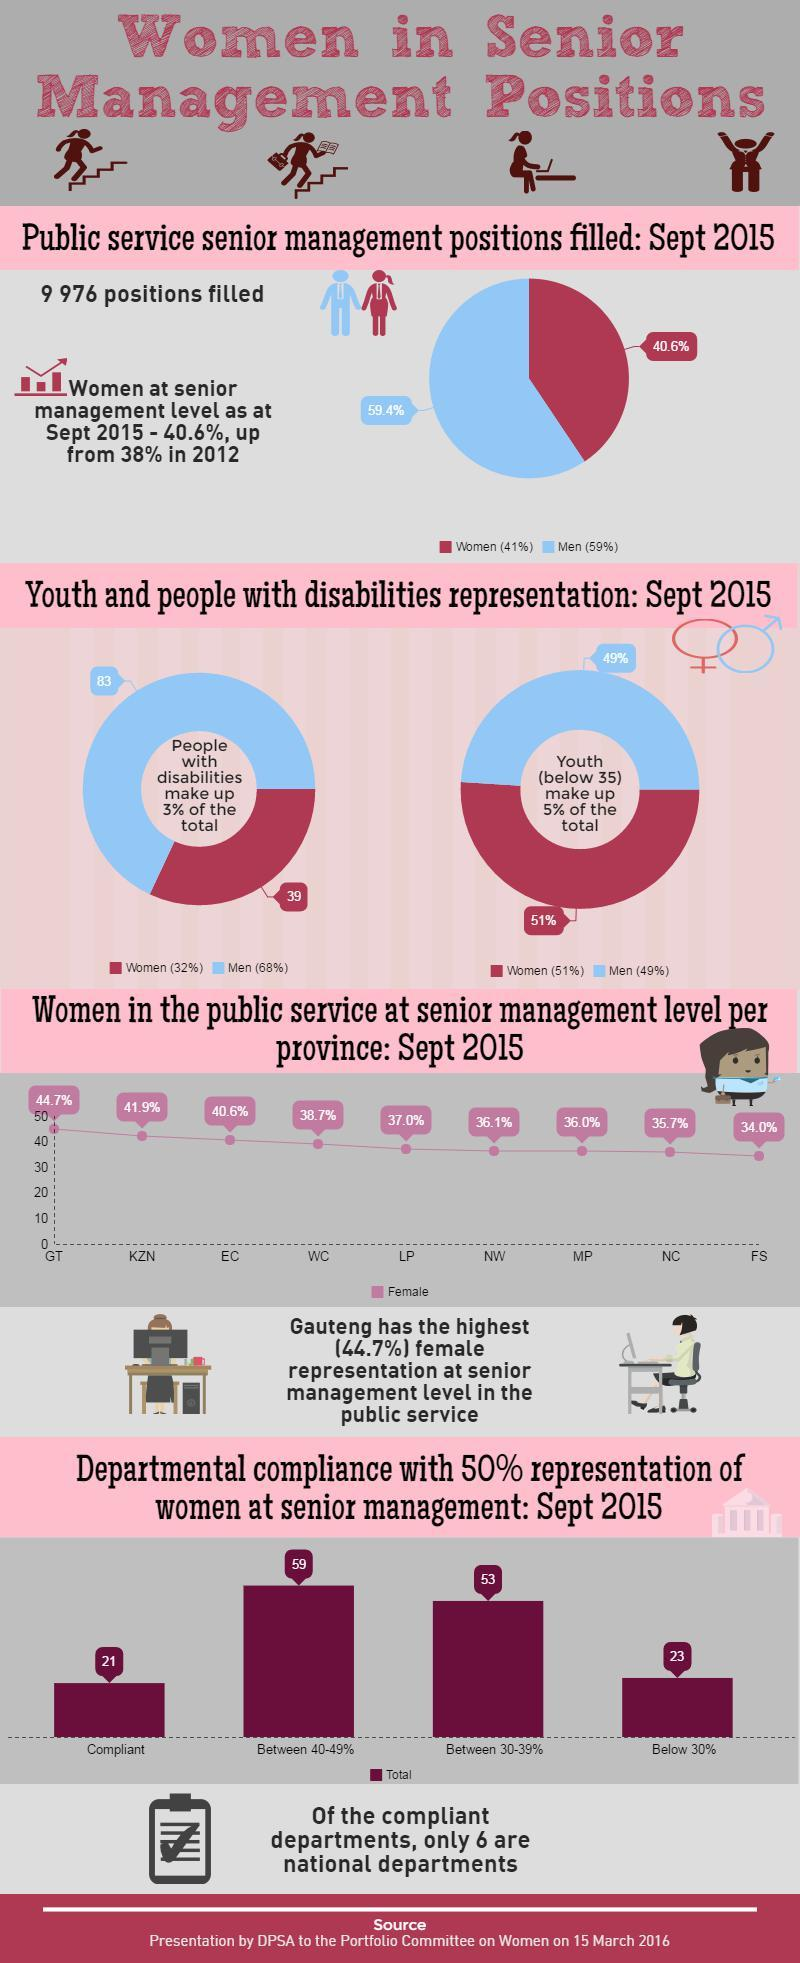Specify some key components in this picture. According to the pie chart provided, in September 2015, 40.6% of females occupied senior management positions in the public service. In the period from 2012 to 2014, there was a rise of 2.6% in the number of women holding senior management positions. 